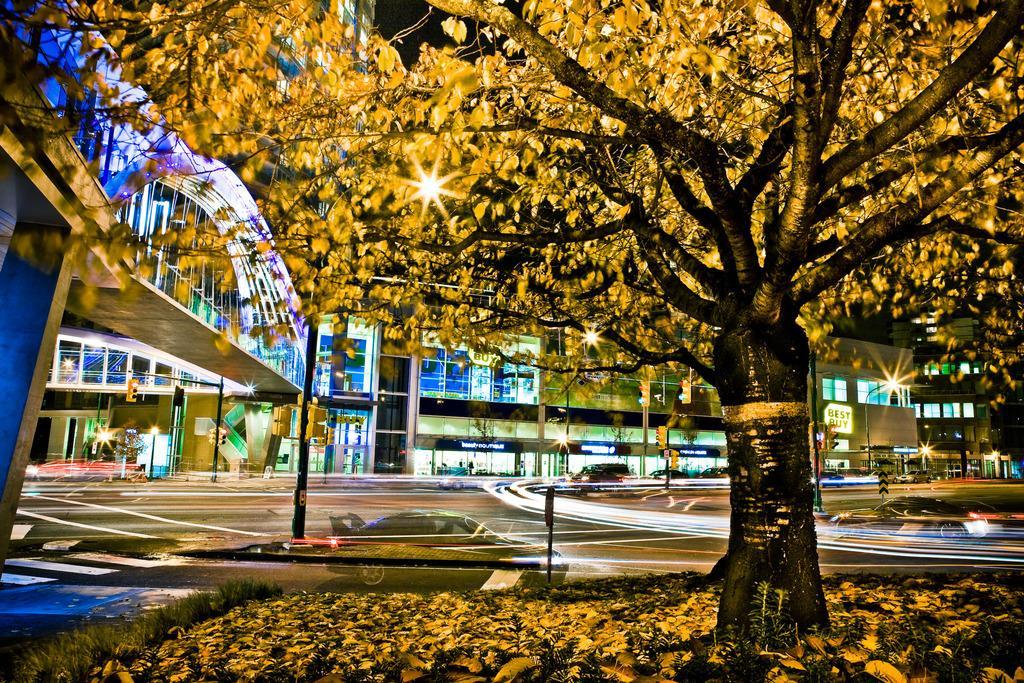Could you give a brief overview of what you see in this image? In the image we can see there is a tree and there are dry leaves on the ground. There are buildings and there is a reflection of car parked on the road. There are street light poles and there are cars parked on the road. 